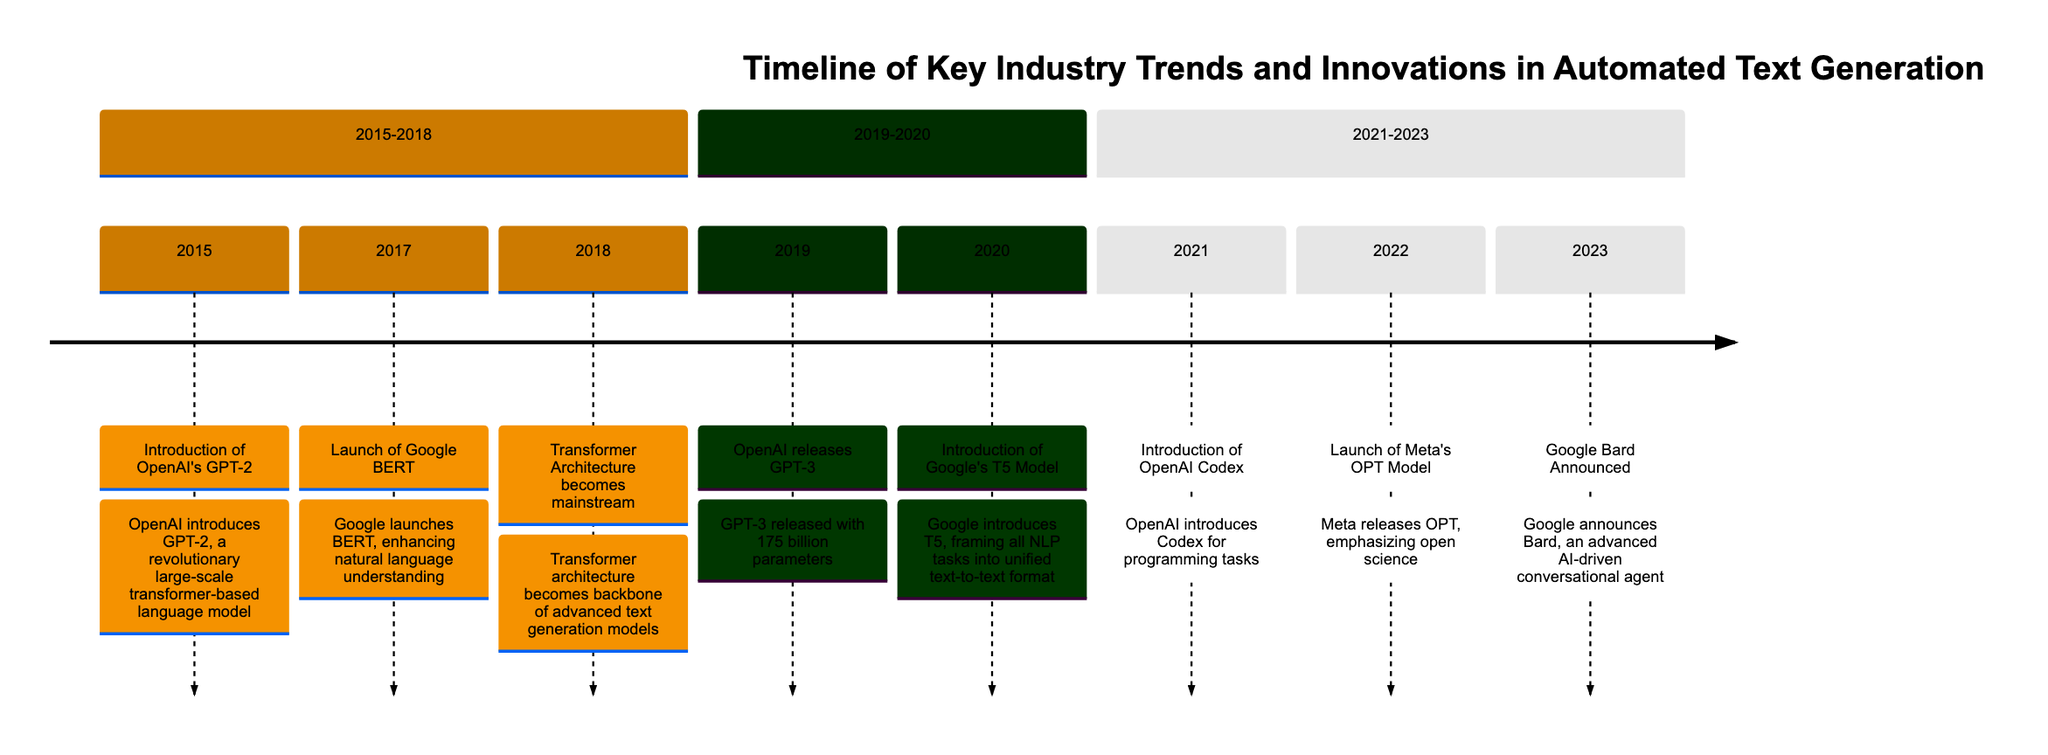What significant development occurred in 2015? The diagram indicates that in 2015, OpenAI introduced GPT-2, which is noted for being a revolutionary large-scale transformer-based language model.
Answer: Introduction of OpenAI's GPT-2 Which model was launched by Google in 2017? Referring to the timeline, the event for 2017 shows that Google launched the BERT model, which is focused on enhancing natural language understanding.
Answer: Launch of Google BERT How many parameters does GPT-3 have? The timeline specifies that OpenAI released GPT-3 in 2019 with 175 billion parameters, making it a significant advancement in language models.
Answer: 175 billion parameters What major architecture became mainstream in 2018? According to the diagram, in 2018, the Transformer architecture became mainstream, indicating its widespread adoption in advanced text generation models.
Answer: Transformer Architecture becomes mainstream Which company's model emphasized open science in 2022? The diagram reveals that in 2022, Meta released the OPT model, which emphasizes open science in making language models available for research.
Answer: Meta's OPT Model What is the main focus of OpenAI Codex introduced in 2021? The timeline explains that OpenAI Codex was introduced specifically for programming tasks, indicating its role in enabling automated code generation.
Answer: Programming tasks What kind of agent was announced by Google in 2023? Referring to the event in 2023 on the timeline, it states that Google announced Bard, an AI-driven conversational agent designed for natural interactions.
Answer: AI-driven conversational agent During which years were the GPT models (GPT-2 and GPT-3) introduced? By looking at the timeline, one can see that GPT-2 was introduced in 2015 and GPT-3 was released in 2019, indicating a four-year gap between them.
Answer: 2015 and 2019 Which innovation in text generation was introduced with the T5 model? The timeline indicates that, introduced in 2020, Google's T5 model aimed to frame all NLP tasks into a unified text-to-text format, pushing the boundaries of text generation.
Answer: Unified text-to-text format 